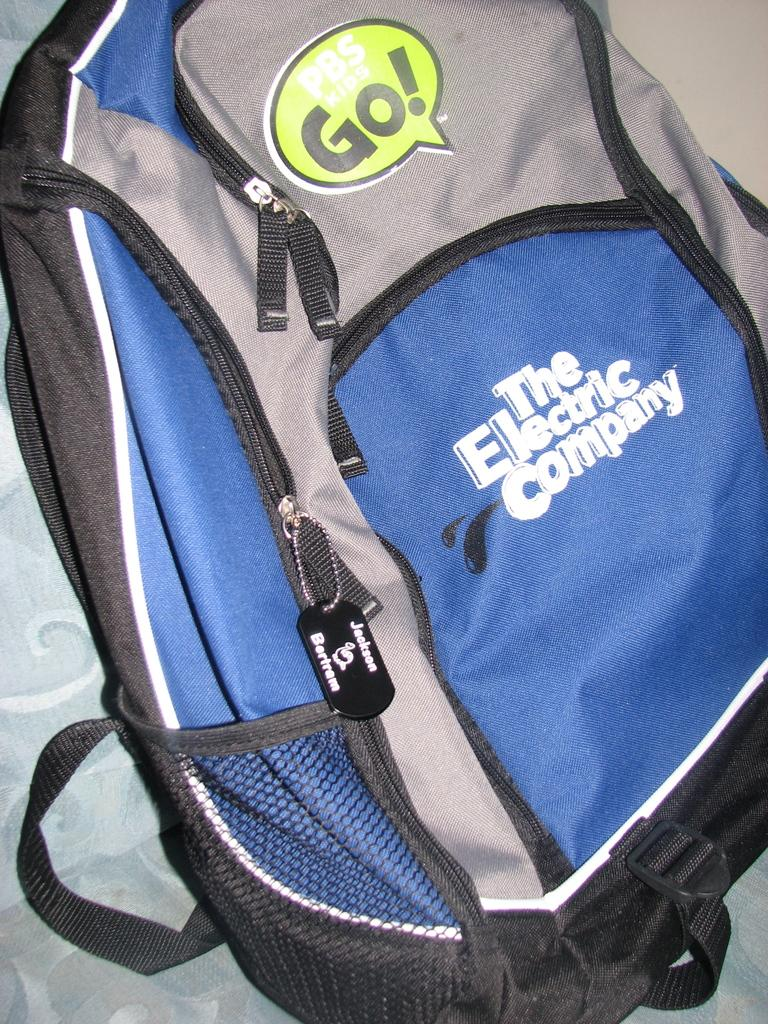<image>
Share a concise interpretation of the image provided. A backpack which has The Electric Company  written on it. 